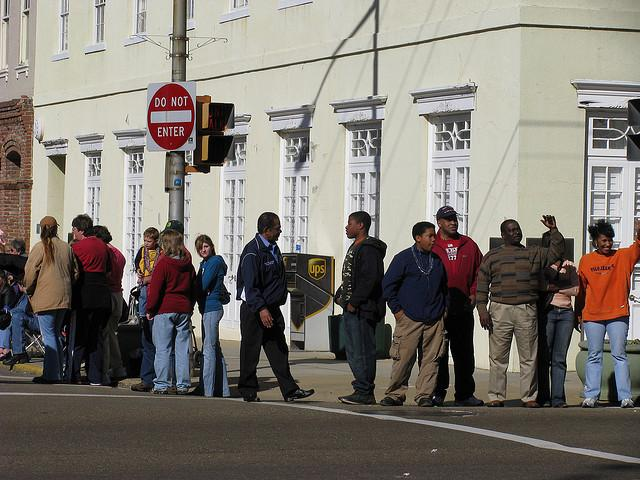What is under the red and white sign? people 